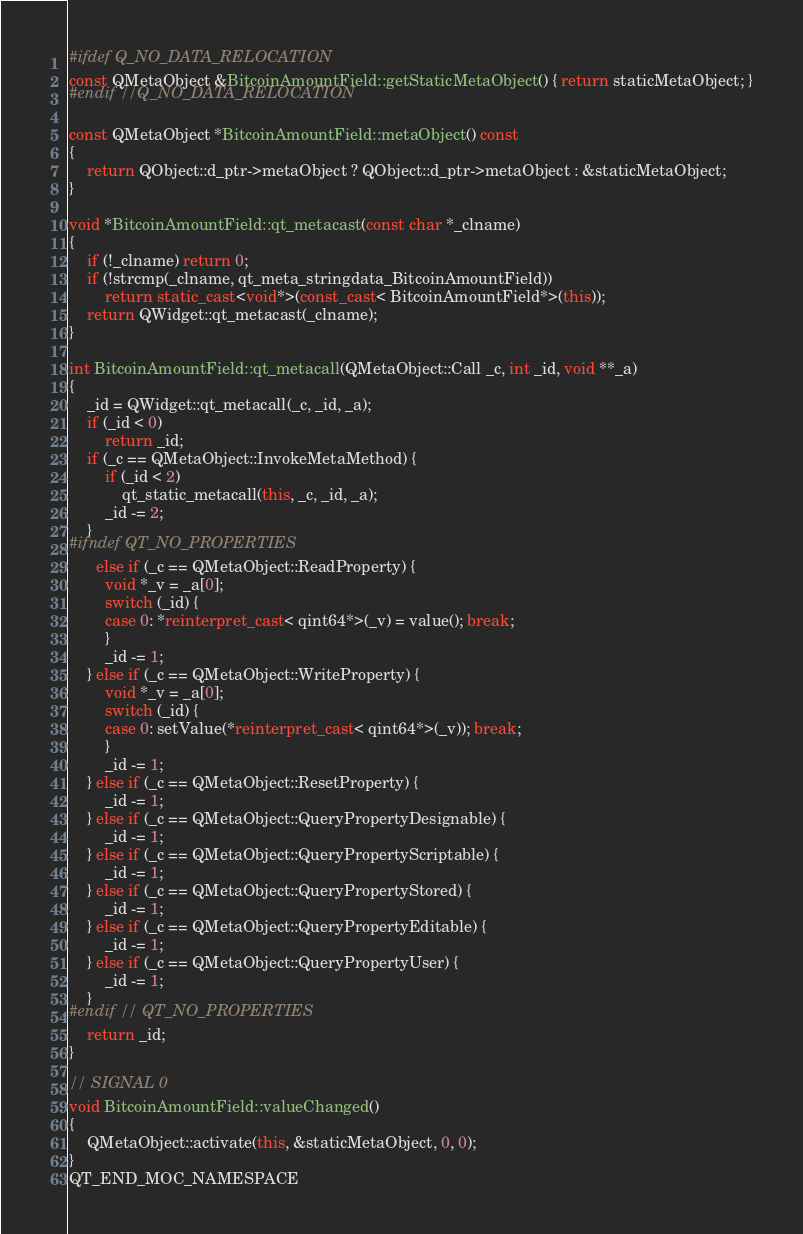Convert code to text. <code><loc_0><loc_0><loc_500><loc_500><_C++_>#ifdef Q_NO_DATA_RELOCATION
const QMetaObject &BitcoinAmountField::getStaticMetaObject() { return staticMetaObject; }
#endif //Q_NO_DATA_RELOCATION

const QMetaObject *BitcoinAmountField::metaObject() const
{
    return QObject::d_ptr->metaObject ? QObject::d_ptr->metaObject : &staticMetaObject;
}

void *BitcoinAmountField::qt_metacast(const char *_clname)
{
    if (!_clname) return 0;
    if (!strcmp(_clname, qt_meta_stringdata_BitcoinAmountField))
        return static_cast<void*>(const_cast< BitcoinAmountField*>(this));
    return QWidget::qt_metacast(_clname);
}

int BitcoinAmountField::qt_metacall(QMetaObject::Call _c, int _id, void **_a)
{
    _id = QWidget::qt_metacall(_c, _id, _a);
    if (_id < 0)
        return _id;
    if (_c == QMetaObject::InvokeMetaMethod) {
        if (_id < 2)
            qt_static_metacall(this, _c, _id, _a);
        _id -= 2;
    }
#ifndef QT_NO_PROPERTIES
      else if (_c == QMetaObject::ReadProperty) {
        void *_v = _a[0];
        switch (_id) {
        case 0: *reinterpret_cast< qint64*>(_v) = value(); break;
        }
        _id -= 1;
    } else if (_c == QMetaObject::WriteProperty) {
        void *_v = _a[0];
        switch (_id) {
        case 0: setValue(*reinterpret_cast< qint64*>(_v)); break;
        }
        _id -= 1;
    } else if (_c == QMetaObject::ResetProperty) {
        _id -= 1;
    } else if (_c == QMetaObject::QueryPropertyDesignable) {
        _id -= 1;
    } else if (_c == QMetaObject::QueryPropertyScriptable) {
        _id -= 1;
    } else if (_c == QMetaObject::QueryPropertyStored) {
        _id -= 1;
    } else if (_c == QMetaObject::QueryPropertyEditable) {
        _id -= 1;
    } else if (_c == QMetaObject::QueryPropertyUser) {
        _id -= 1;
    }
#endif // QT_NO_PROPERTIES
    return _id;
}

// SIGNAL 0
void BitcoinAmountField::valueChanged()
{
    QMetaObject::activate(this, &staticMetaObject, 0, 0);
}
QT_END_MOC_NAMESPACE
</code> 